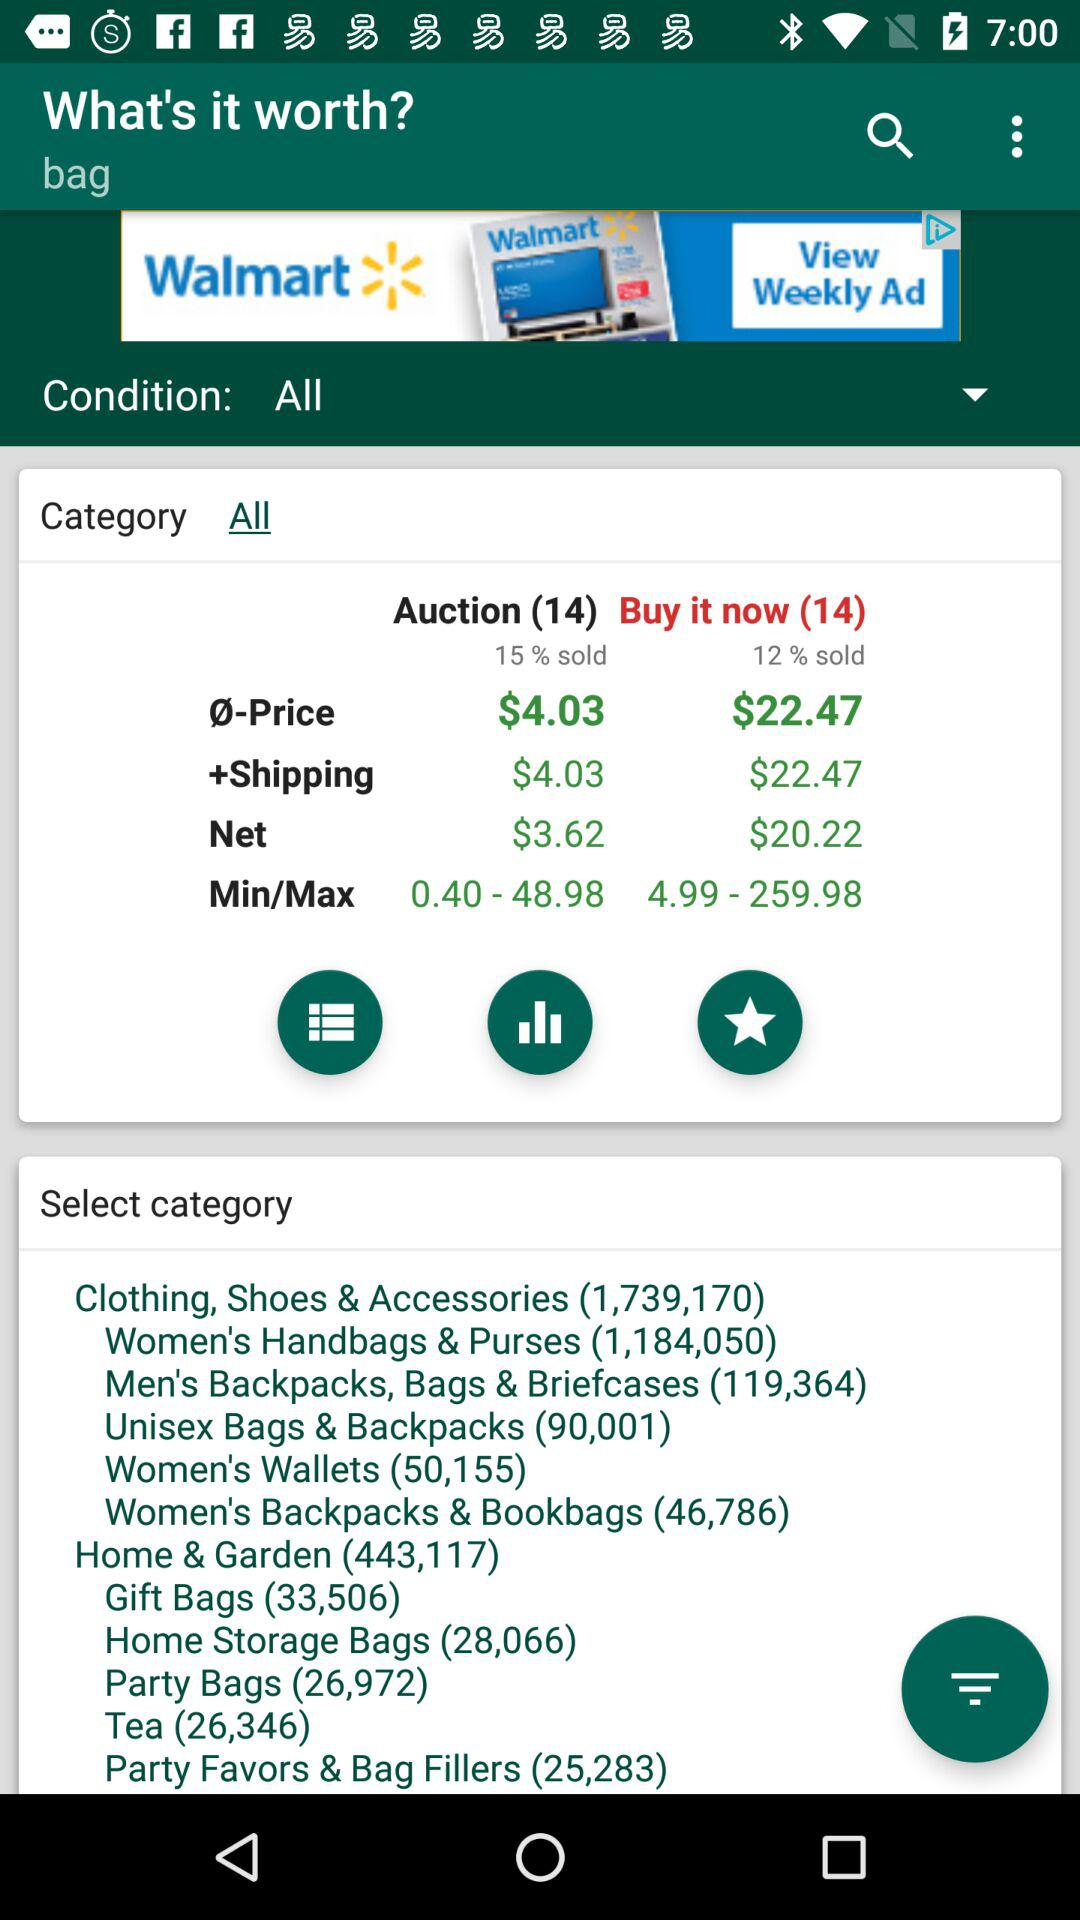What is the minimum and maximum "Buy it now" price? The minimum and maximum "Buy it now" prices are 4.99 and 259.98. 